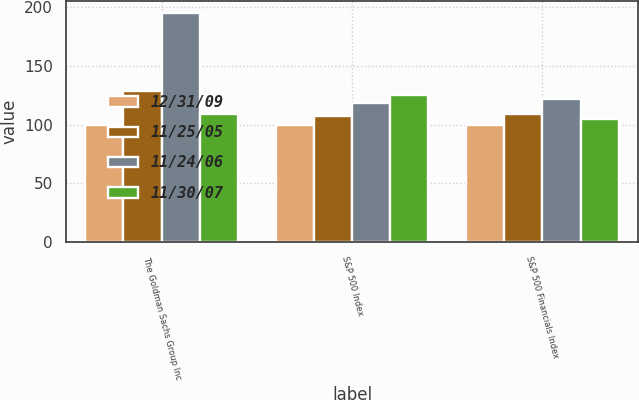Convert chart. <chart><loc_0><loc_0><loc_500><loc_500><stacked_bar_chart><ecel><fcel>The Goldman Sachs Group Inc<fcel>S&P 500 Index<fcel>S&P 500 Financials Index<nl><fcel>12/31/09<fcel>100<fcel>100<fcel>100<nl><fcel>11/25/05<fcel>129.09<fcel>107.24<fcel>109.49<nl><fcel>11/24/06<fcel>195.63<fcel>118.46<fcel>121.69<nl><fcel>11/30/07<fcel>109.49<fcel>125.24<fcel>104.7<nl></chart> 